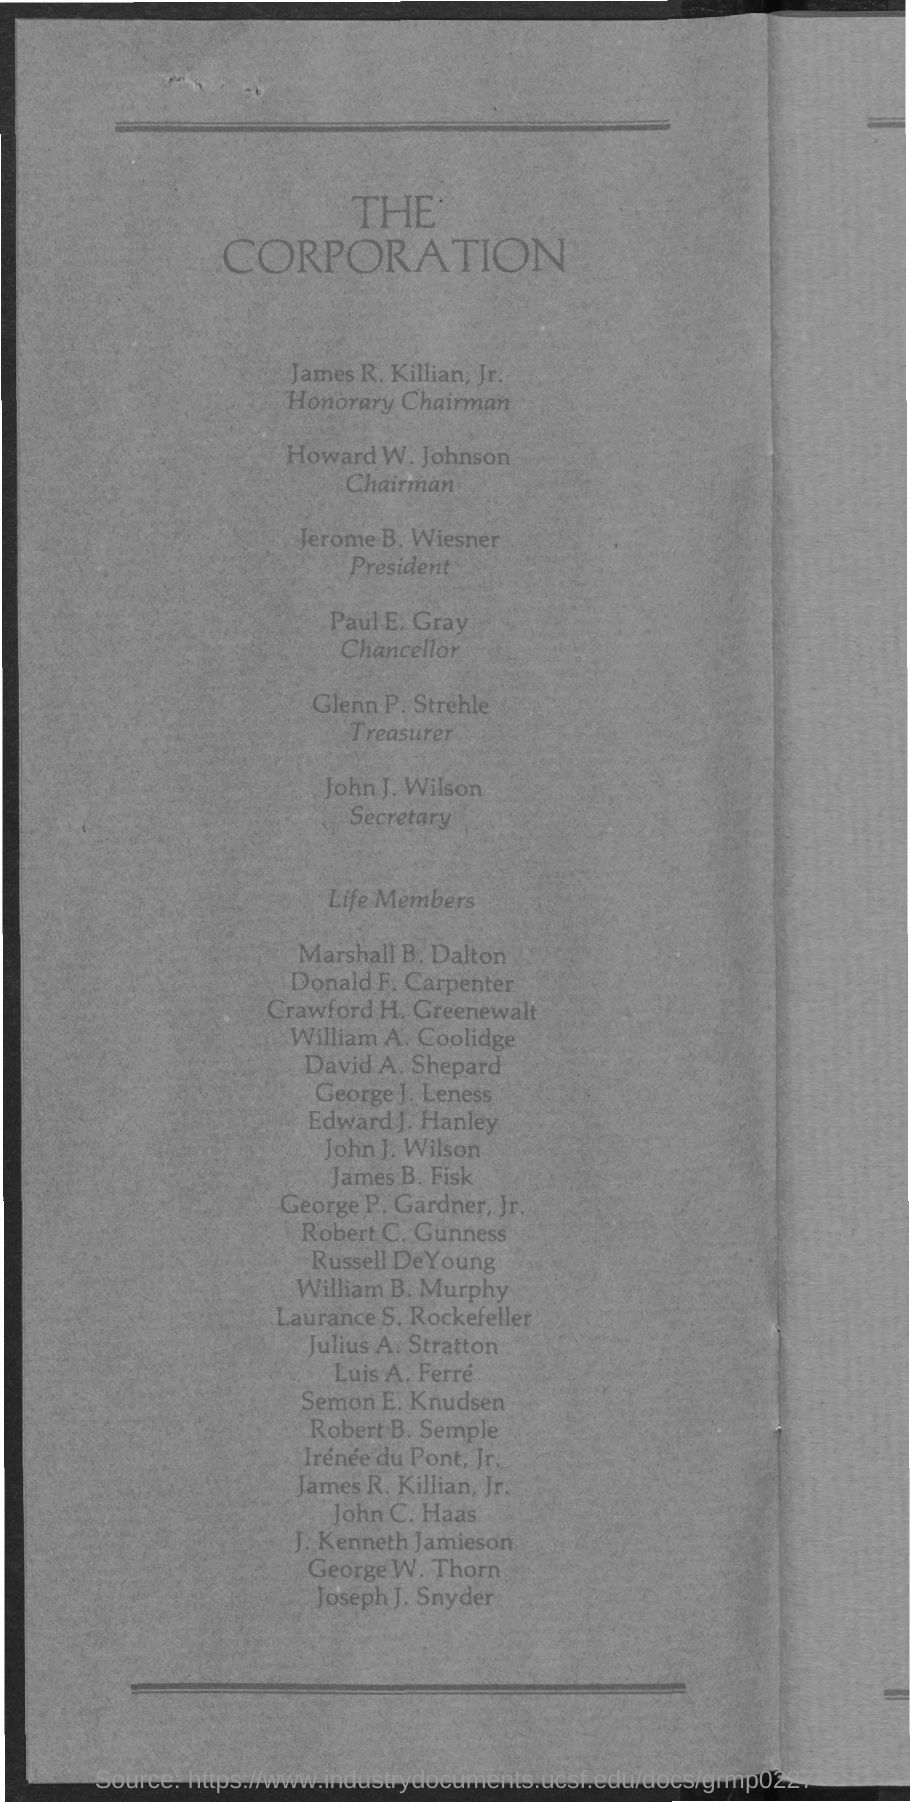Draw attention to some important aspects in this diagram. The identity of the Chancellor is Paul E. Gray. Jerome b. Wiesner is the President. The Honorary Chairman is James R. Killian. The Secretary is John J. Wilson. The individual who holds the position of Chairman is Howard W. Johnson. 